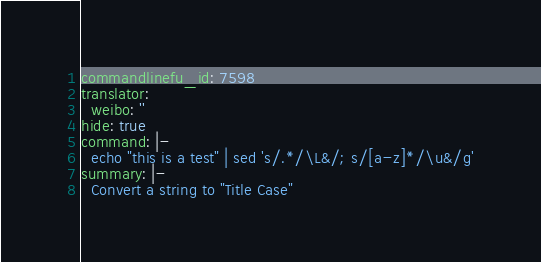Convert code to text. <code><loc_0><loc_0><loc_500><loc_500><_YAML_>commandlinefu_id: 7598
translator:
  weibo: ''
hide: true
command: |-
  echo "this is a test" | sed 's/.*/\L&/; s/[a-z]*/\u&/g'
summary: |-
  Convert a string to "Title Case"
</code> 